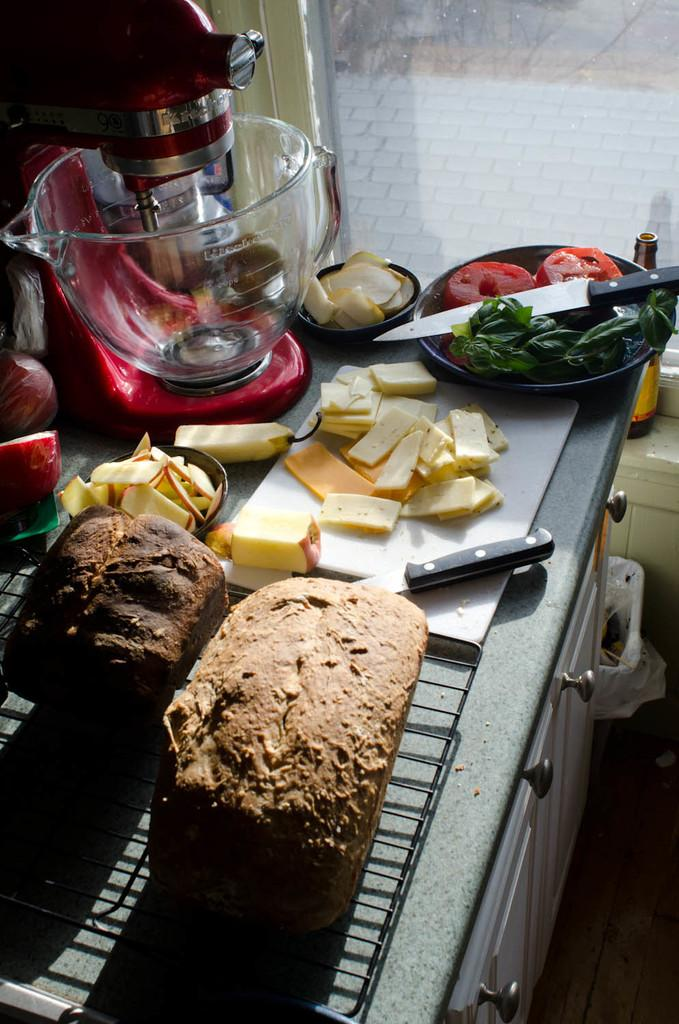What type of furniture is present in the image? There is a drawer table in the image. What items can be found inside the drawer table? The drawer table contains bread, apple slices, knives, vegetables, and plates. What additional appliance is present on the drawer table? There is a food mixer on the drawer table. Is there any indication of the presence of a window in the image? Yes, there is a bottle in front of a window in the image. What type of fruit is being sold on the street in the image? There is no indication of a street or fruit being sold in the image. 